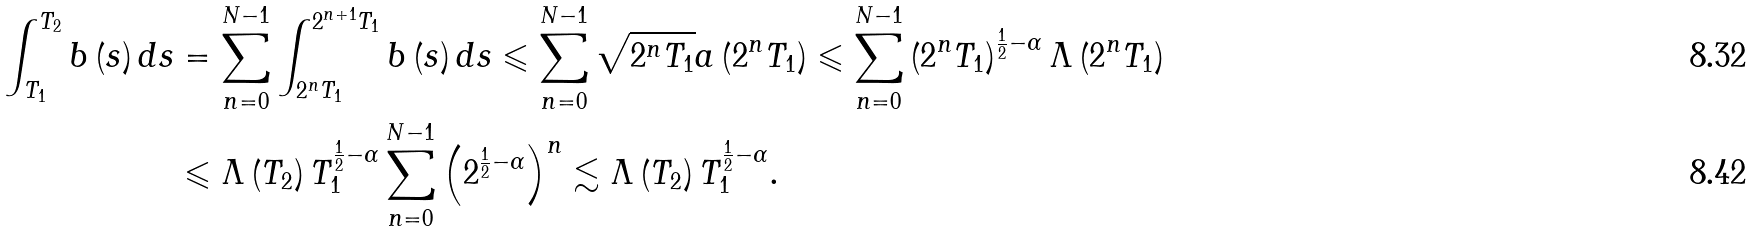Convert formula to latex. <formula><loc_0><loc_0><loc_500><loc_500>\int _ { T _ { 1 } } ^ { T _ { 2 } } b \left ( s \right ) d s & = \sum _ { n = 0 } ^ { N - 1 } \int _ { 2 ^ { n } T _ { 1 } } ^ { 2 ^ { n + 1 } T _ { 1 } } b \left ( s \right ) d s \leqslant \sum _ { n = 0 } ^ { N - 1 } \sqrt { 2 ^ { n } T _ { 1 } } a \left ( 2 ^ { n } T _ { 1 } \right ) \leqslant \sum _ { n = 0 } ^ { N - 1 } \left ( 2 ^ { n } T _ { 1 } \right ) ^ { \frac { 1 } { 2 } - \alpha } \Lambda \left ( 2 ^ { n } T _ { 1 } \right ) \\ & \leqslant \Lambda \left ( T _ { 2 } \right ) T _ { 1 } ^ { \frac { 1 } { 2 } - \alpha } \sum _ { n = 0 } ^ { N - 1 } \left ( 2 ^ { \frac { 1 } { 2 } - \alpha } \right ) ^ { n } \lesssim \Lambda \left ( T _ { 2 } \right ) T _ { 1 } ^ { \frac { 1 } { 2 } - \alpha } .</formula> 